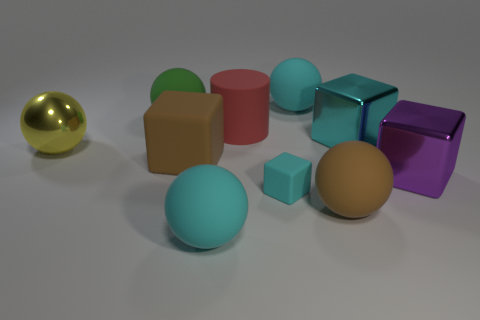There is a shiny cube that is the same color as the small matte object; what is its size?
Your response must be concise. Large. There is a big cyan sphere that is in front of the red matte cylinder; how many big purple things are on the left side of it?
Offer a terse response. 0. Do the purple metallic thing and the block on the left side of the small block have the same size?
Keep it short and to the point. Yes. Is there another matte object of the same color as the tiny object?
Offer a very short reply. Yes. There is a cyan cube that is the same material as the red object; what size is it?
Your response must be concise. Small. Is the cylinder made of the same material as the big yellow thing?
Your answer should be compact. No. The tiny block that is right of the brown thing that is on the left side of the cyan object that is behind the big cyan block is what color?
Your answer should be compact. Cyan. The yellow thing is what shape?
Offer a very short reply. Sphere. There is a tiny cube; is its color the same as the big metallic cube behind the yellow metallic ball?
Offer a very short reply. Yes. Is the number of tiny cyan matte blocks to the right of the large purple metal thing the same as the number of tiny matte cylinders?
Offer a very short reply. Yes. 